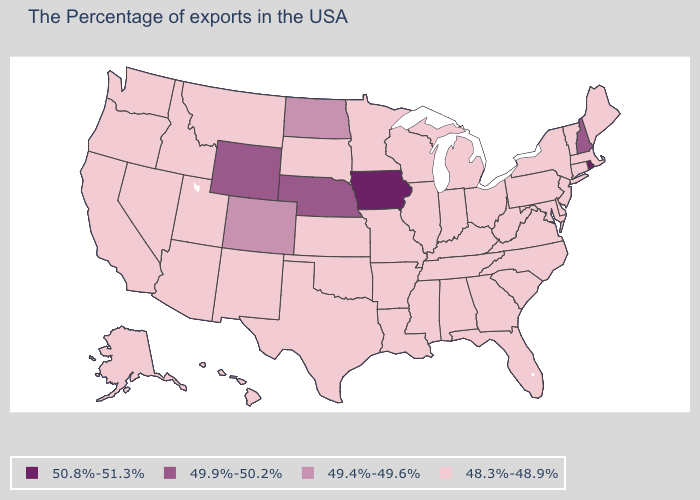Does Kansas have the lowest value in the USA?
Concise answer only. Yes. What is the value of Kansas?
Keep it brief. 48.3%-48.9%. What is the value of Oklahoma?
Answer briefly. 48.3%-48.9%. What is the value of Virginia?
Short answer required. 48.3%-48.9%. Among the states that border Oklahoma , which have the lowest value?
Concise answer only. Missouri, Arkansas, Kansas, Texas, New Mexico. Name the states that have a value in the range 49.4%-49.6%?
Keep it brief. North Dakota, Colorado. Is the legend a continuous bar?
Write a very short answer. No. Does Nevada have the same value as Wyoming?
Short answer required. No. What is the value of Mississippi?
Answer briefly. 48.3%-48.9%. Name the states that have a value in the range 49.4%-49.6%?
Keep it brief. North Dakota, Colorado. What is the value of New Hampshire?
Write a very short answer. 49.9%-50.2%. Does Iowa have the highest value in the USA?
Give a very brief answer. Yes. Does Maryland have the same value as New York?
Give a very brief answer. Yes. What is the value of Wyoming?
Quick response, please. 49.9%-50.2%. 